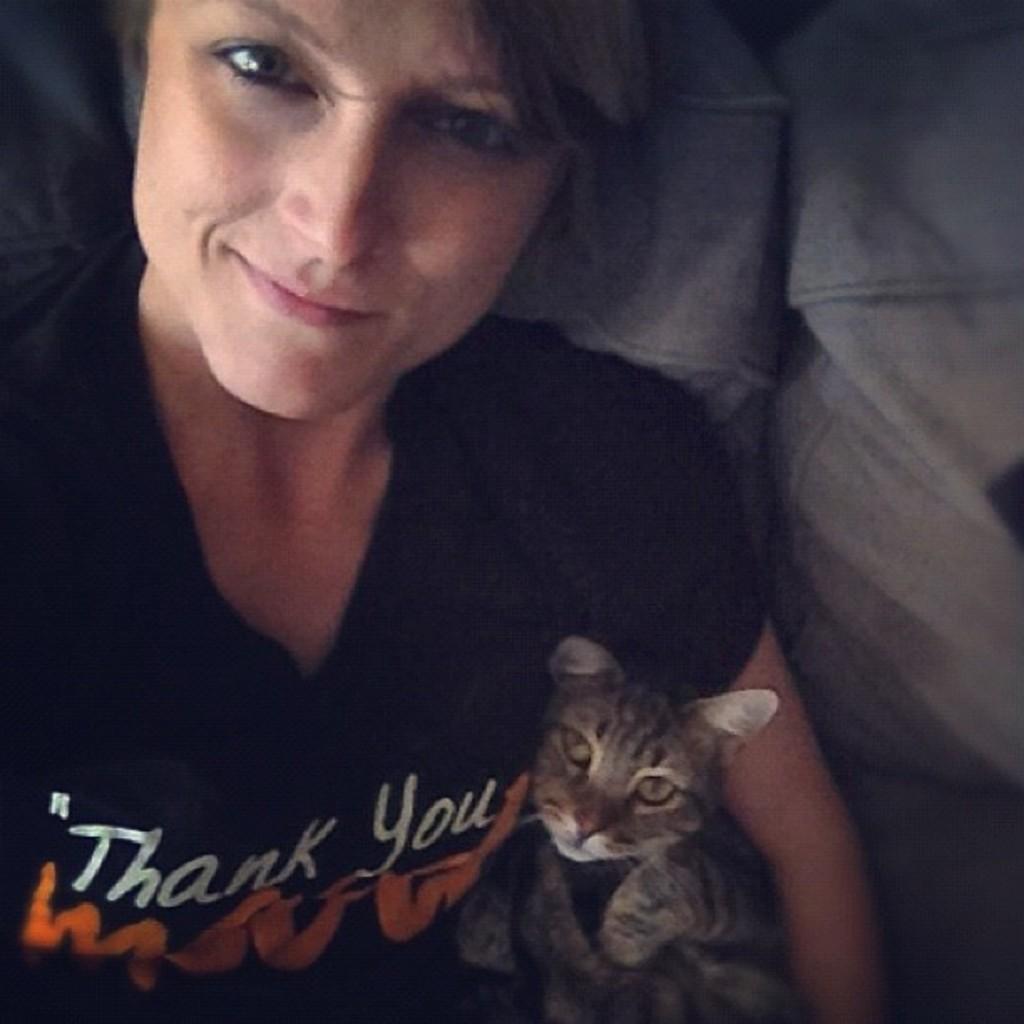Describe this image in one or two sentences. In this picture we can see a woman sitting in a couch and holding cat. 